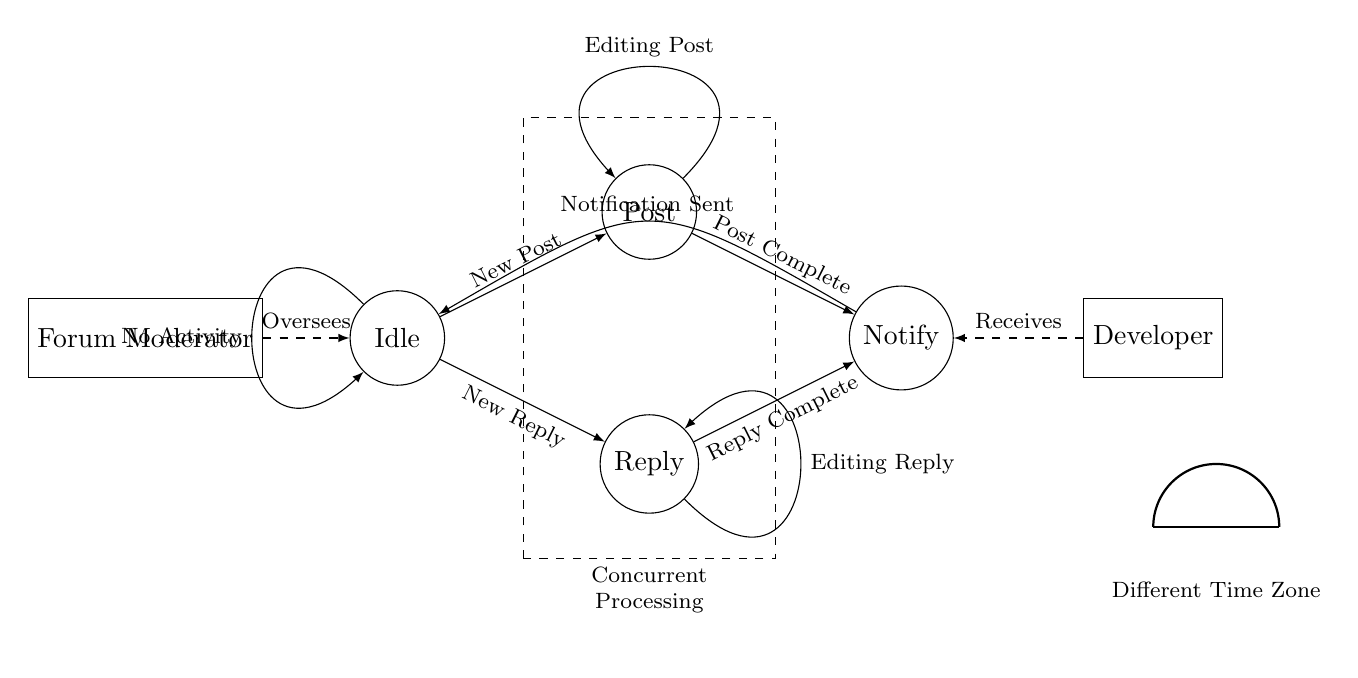What is the initial state of the asynchronous state machine? The initial state is marked as "Idle," which is the starting point of operations in this diagram. This state signifies that no actions are currently being performed.
Answer: Idle What triggers a transition from the idle state? A transition from the idle state can be triggered by either "New Post" or "New Reply," which are pathways leading out from the idle state. These signal the start of new activities.
Answer: New Post, New Reply How many states are represented in the diagram? There are four distinct states shown in the diagram: Idle, Post, Reply, and Notify. Each plays a unique role in managing forum interactions.
Answer: Four What does the forum moderator do in this circuit? The forum moderator is responsible for overseeing the idle state by supervising the system's overall activity and ensuring it operates correctly.
Answer: Oversees What signifies concurrent processing in the diagram? The dashed rectangle around the post and reply states indicates concurrent processing, illustrating that actions in these states can occur simultaneously.
Answer: Dashed rectangle What leads to the notify state? The notify state is reached by completing either a post or a reply, specifically when "Post Complete" or "Reply Complete" events occur, indicating the respective actions have finished.
Answer: Post Complete, Reply Complete In which state does the developer receive notifications? The developer receives notifications in the notify state, where they are informed of the happenings in the forum after post or reply actions are completed.
Answer: Notify 